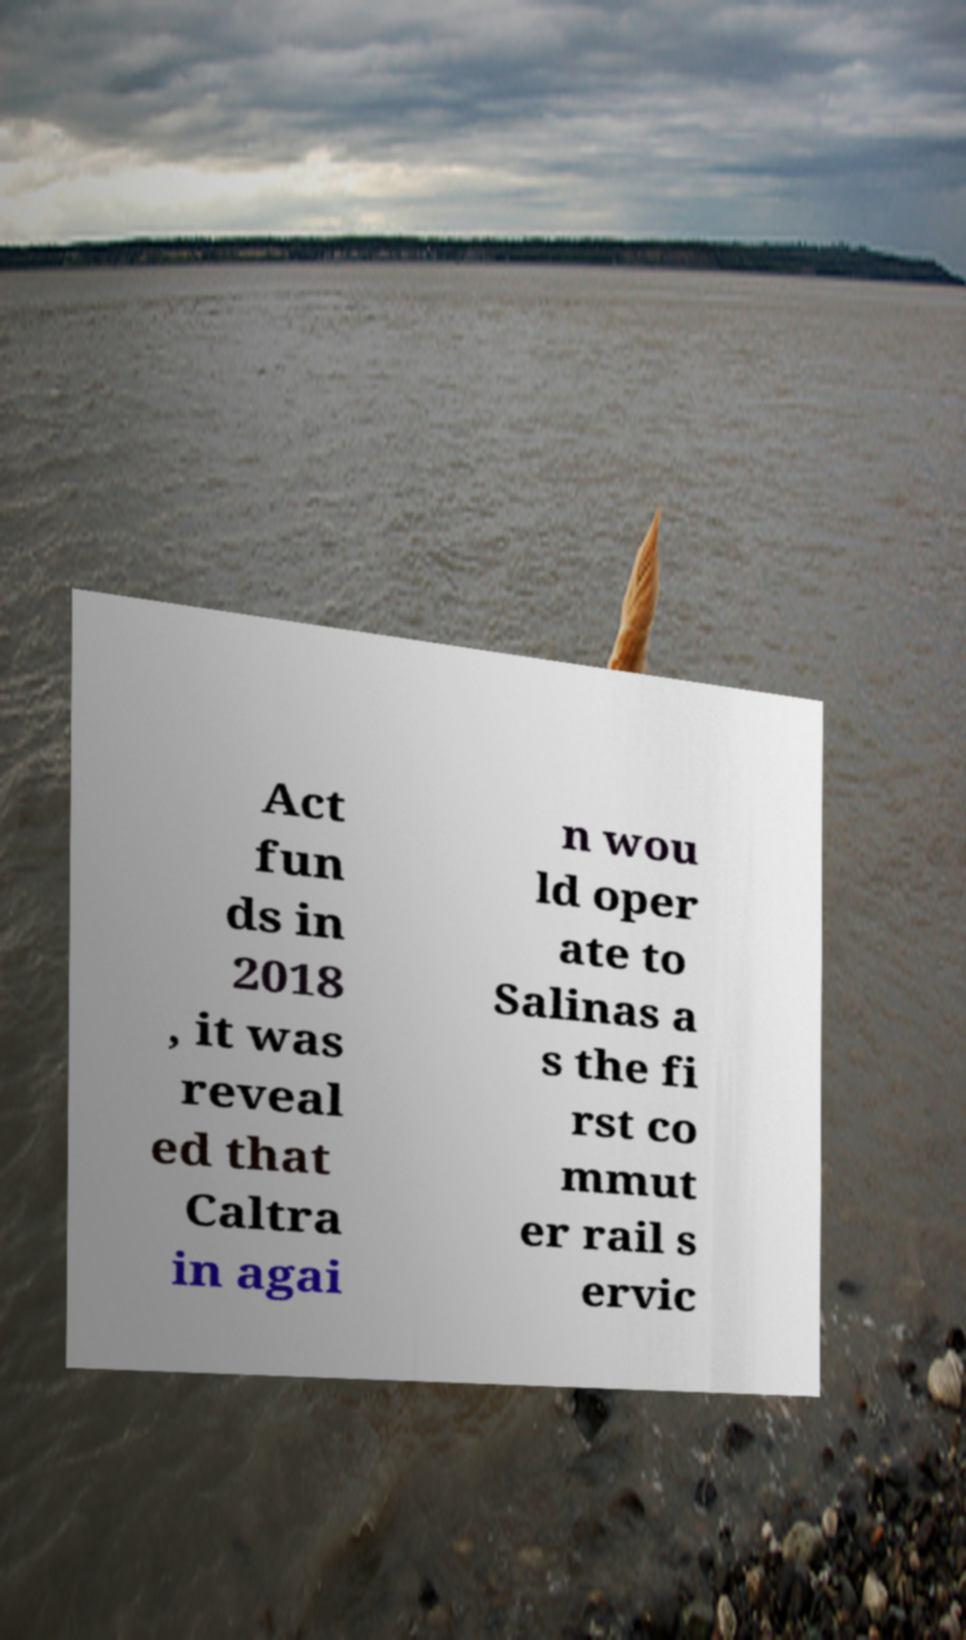What messages or text are displayed in this image? I need them in a readable, typed format. Act fun ds in 2018 , it was reveal ed that Caltra in agai n wou ld oper ate to Salinas a s the fi rst co mmut er rail s ervic 